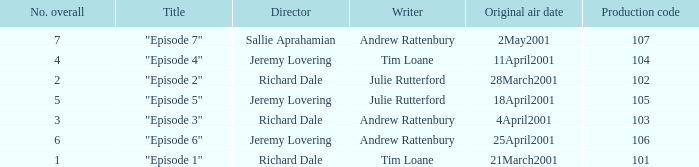What is the highest production code of an episode written by Tim Loane? 104.0. 